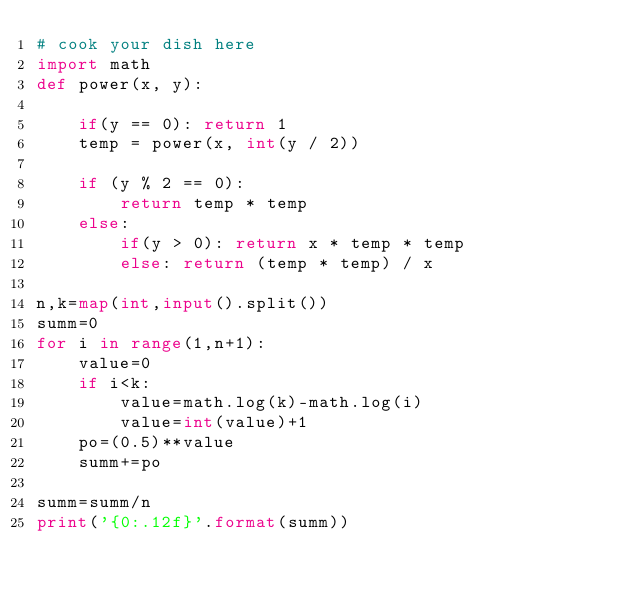<code> <loc_0><loc_0><loc_500><loc_500><_Python_># cook your dish here
import math
def power(x, y): 
  
    if(y == 0): return 1
    temp = power(x, int(y / 2))  
      
    if (y % 2 == 0): 
        return temp * temp 
    else: 
        if(y > 0): return x * temp * temp 
        else: return (temp * temp) / x 
        
n,k=map(int,input().split())
summ=0
for i in range(1,n+1):
    value=0
    if i<k:
        value=math.log(k)-math.log(i)
        value=int(value)+1
    po=(0.5)**value
    summ+=po
    
summ=summ/n
print('{0:.12f}'.format(summ))</code> 